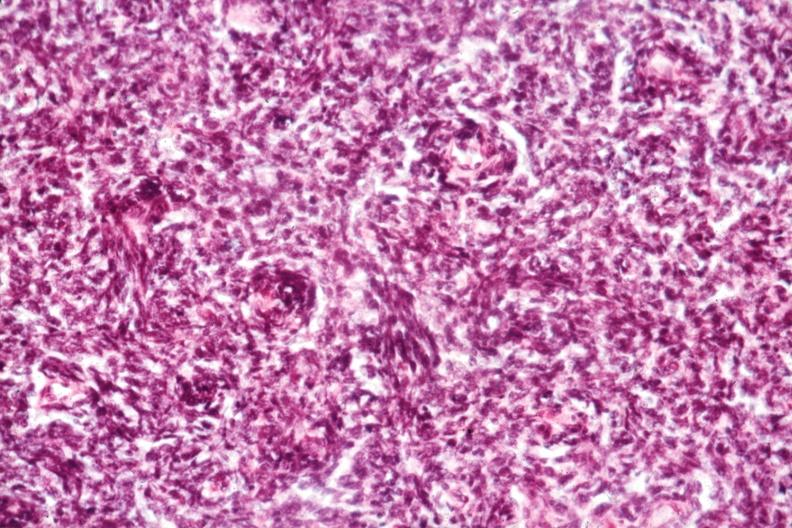s mucinous cystadenocarcinoma present?
Answer the question using a single word or phrase. No 